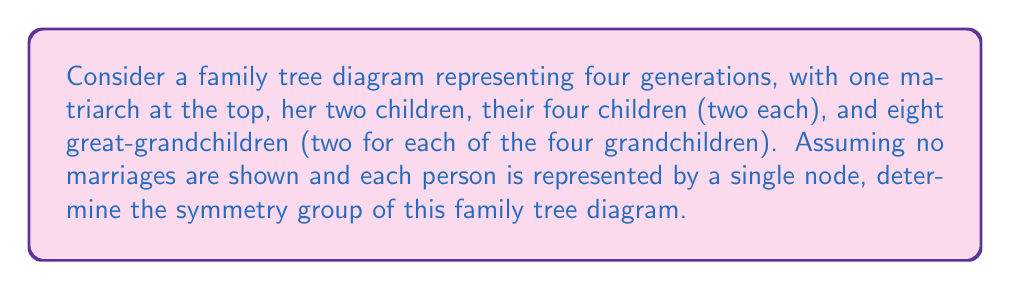Teach me how to tackle this problem. Let's approach this step-by-step:

1) First, we need to visualize the family tree:
   [asy]
   unitsize(1cm);
   dot((0,3)); // Matriarch
   dot((-1,2)); dot((1,2)); // Children
   dot((-1.5,1)); dot((-0.5,1)); dot((0.5,1)); dot((1.5,1)); // Grandchildren
   for(int i=-3; i<=3; ++i) {
     dot((i*0.5,0)); // Great-grandchildren
   }
   draw((0,3)--(-1,2)--(1,2));
   draw((-1,2)--(-1.5,1)--(-0.5,1));
   draw((1,2)--(0.5,1)--(1.5,1));
   for(int i=-3; i<=1; i+=2) {
     draw((i*0.5,1)--(i*0.25,0)--((i+1)*0.25,0));
   }
   [/asy]

2) The symmetries of this diagram are the operations that leave the structure unchanged. In this case, we can:
   - Swap the two children of the matriarch
   - For each child, swap their two children
   - For each grandchild, swap their two children

3) Mathematically, this group structure is a direct product of several symmetric groups:
   $$G = S_2 \times (S_2 \times S_2) \times (S_2 \times S_2 \times S_2 \times S_2)$$

   Where $S_2$ is the symmetric group on 2 elements (i.e., the group with only the identity and a single transposition).

4) To determine the order of this group:
   - $|S_2| = 2$
   - We have 1 $S_2$ for the children level
   - We have 2 $S_2$'s for the grandchildren level
   - We have 4 $S_2$'s for the great-grandchildren level

5) Therefore, the order of the group is:
   $$|G| = 2 \times (2 \times 2) \times (2 \times 2 \times 2 \times 2) = 2^7 = 128$$

6) This group is isomorphic to $(Z_2)^7$, where $Z_2$ is the cyclic group of order 2.
Answer: $(Z_2)^7$ 